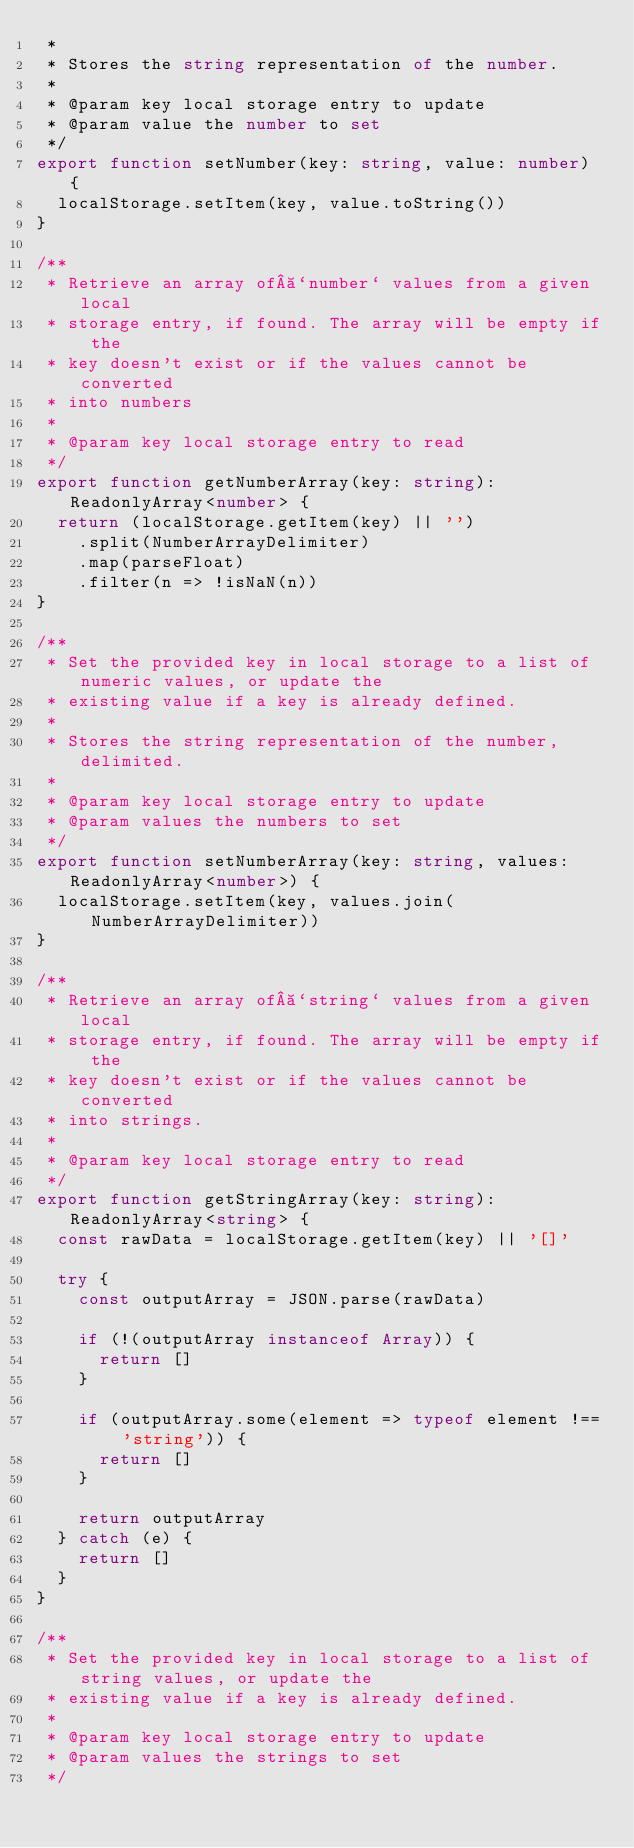<code> <loc_0><loc_0><loc_500><loc_500><_TypeScript_> *
 * Stores the string representation of the number.
 *
 * @param key local storage entry to update
 * @param value the number to set
 */
export function setNumber(key: string, value: number) {
  localStorage.setItem(key, value.toString())
}

/**
 * Retrieve an array of `number` values from a given local
 * storage entry, if found. The array will be empty if the
 * key doesn't exist or if the values cannot be converted
 * into numbers
 *
 * @param key local storage entry to read
 */
export function getNumberArray(key: string): ReadonlyArray<number> {
  return (localStorage.getItem(key) || '')
    .split(NumberArrayDelimiter)
    .map(parseFloat)
    .filter(n => !isNaN(n))
}

/**
 * Set the provided key in local storage to a list of numeric values, or update the
 * existing value if a key is already defined.
 *
 * Stores the string representation of the number, delimited.
 *
 * @param key local storage entry to update
 * @param values the numbers to set
 */
export function setNumberArray(key: string, values: ReadonlyArray<number>) {
  localStorage.setItem(key, values.join(NumberArrayDelimiter))
}

/**
 * Retrieve an array of `string` values from a given local
 * storage entry, if found. The array will be empty if the
 * key doesn't exist or if the values cannot be converted
 * into strings.
 *
 * @param key local storage entry to read
 */
export function getStringArray(key: string): ReadonlyArray<string> {
  const rawData = localStorage.getItem(key) || '[]'

  try {
    const outputArray = JSON.parse(rawData)

    if (!(outputArray instanceof Array)) {
      return []
    }

    if (outputArray.some(element => typeof element !== 'string')) {
      return []
    }

    return outputArray
  } catch (e) {
    return []
  }
}

/**
 * Set the provided key in local storage to a list of string values, or update the
 * existing value if a key is already defined.
 *
 * @param key local storage entry to update
 * @param values the strings to set
 */</code> 